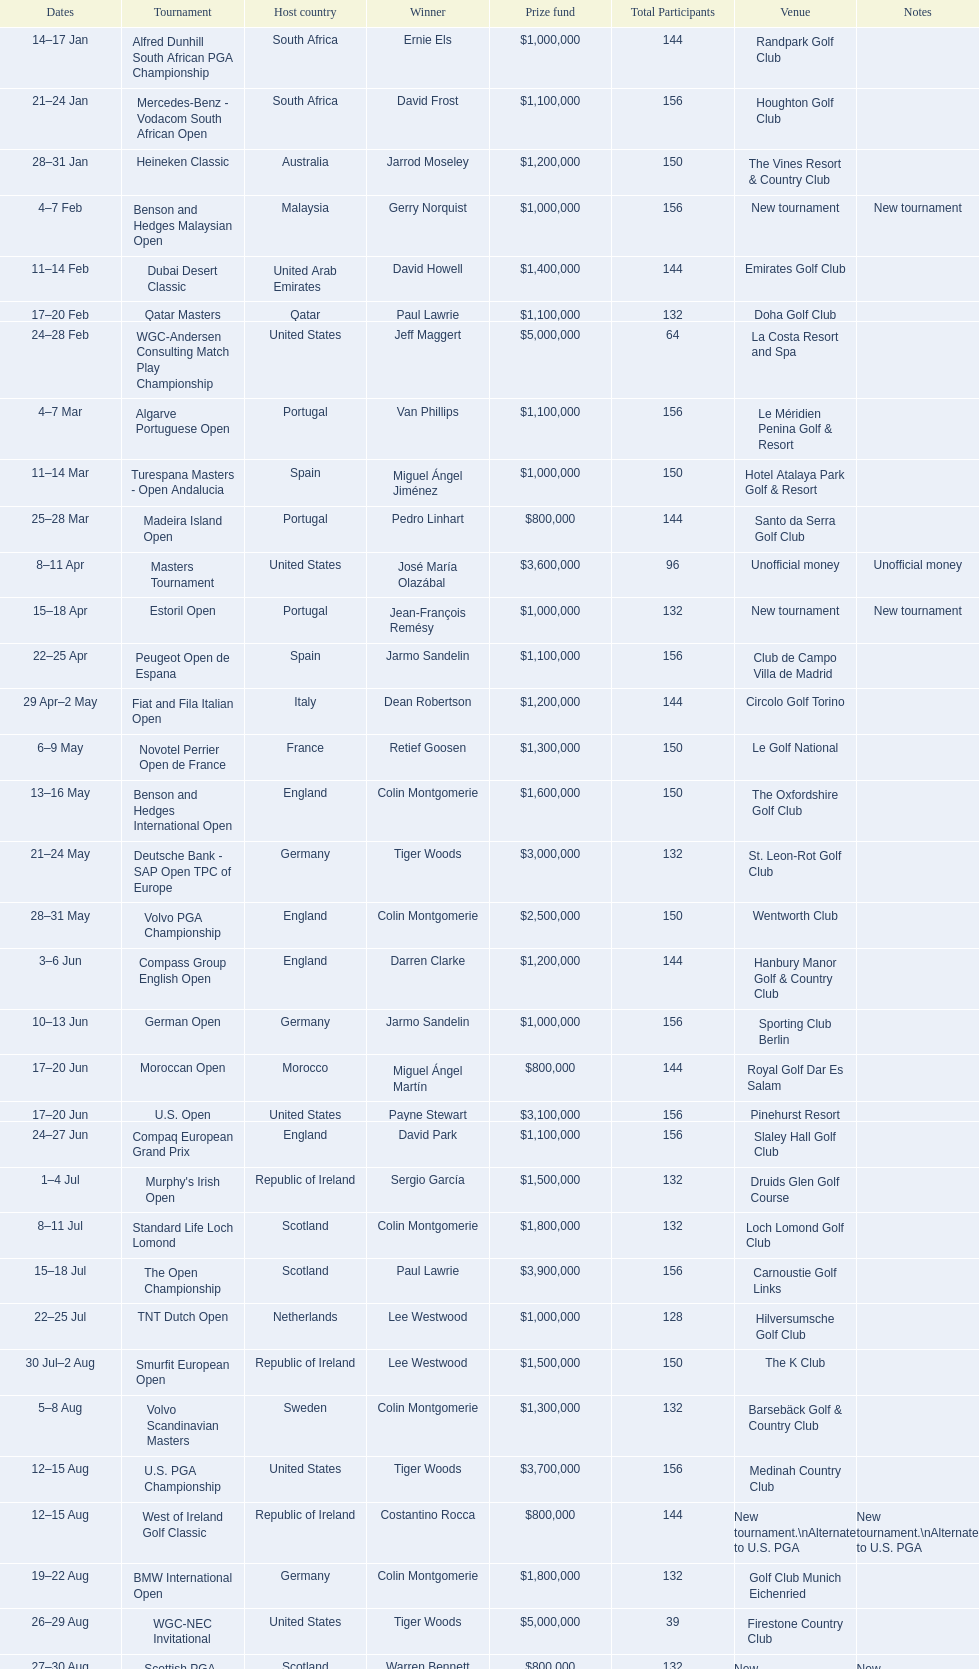How long did the estoril open last? 3 days. 